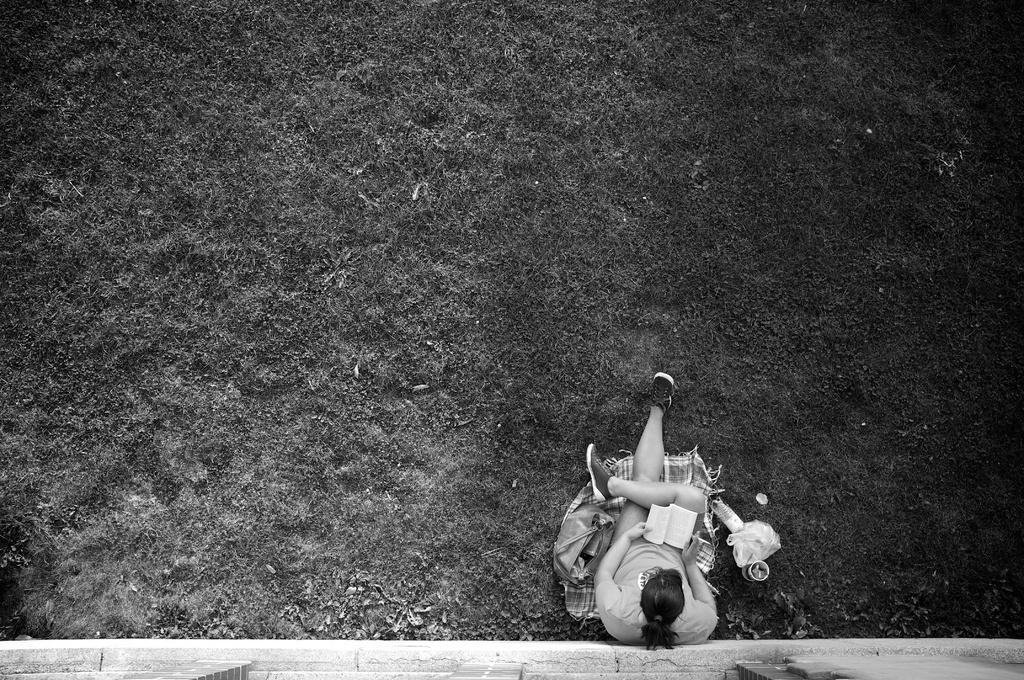In one or two sentences, can you explain what this image depicts? In this picture we can see a person sitting and reading a book. There is a bag, cup, cloth, cover, bottle and few other things on the ground. Some grass is visible on the ground. 